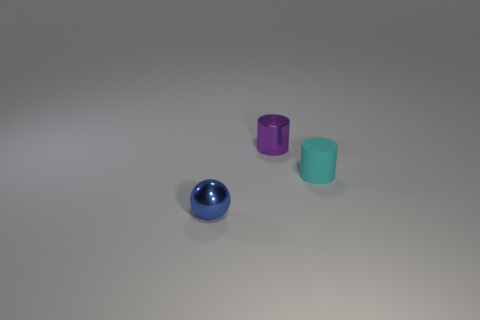Subtract all green balls. Subtract all gray cylinders. How many balls are left? 1 Add 1 tiny purple matte objects. How many objects exist? 4 Subtract all spheres. How many objects are left? 2 Add 2 tiny cyan cylinders. How many tiny cyan cylinders exist? 3 Subtract 1 purple cylinders. How many objects are left? 2 Subtract all tiny rubber things. Subtract all large yellow objects. How many objects are left? 2 Add 1 tiny purple cylinders. How many tiny purple cylinders are left? 2 